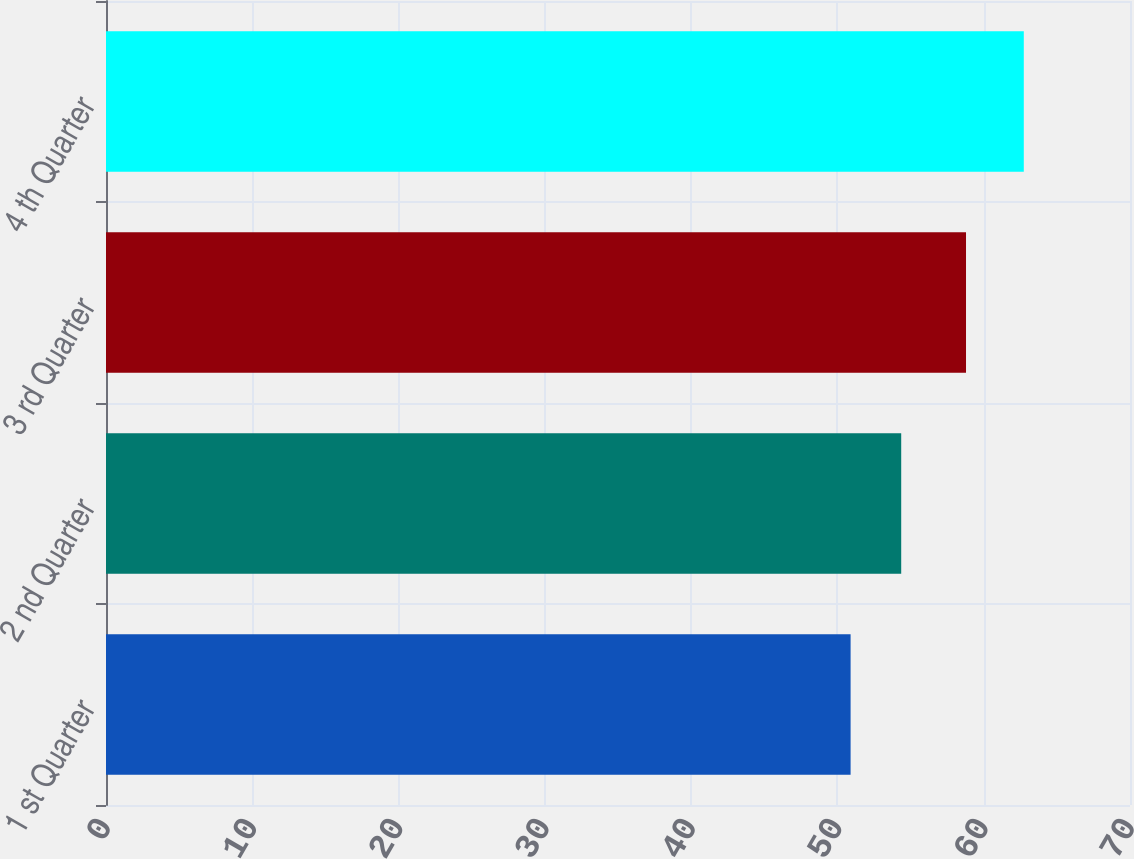Convert chart to OTSL. <chart><loc_0><loc_0><loc_500><loc_500><bar_chart><fcel>1 st Quarter<fcel>2 nd Quarter<fcel>3 rd Quarter<fcel>4 th Quarter<nl><fcel>50.9<fcel>54.36<fcel>58.79<fcel>62.74<nl></chart> 